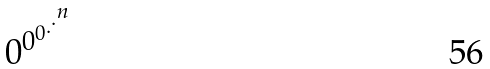<formula> <loc_0><loc_0><loc_500><loc_500>0 ^ { 0 ^ { 0 ^ { . ^ { . ^ { n } } } } }</formula> 